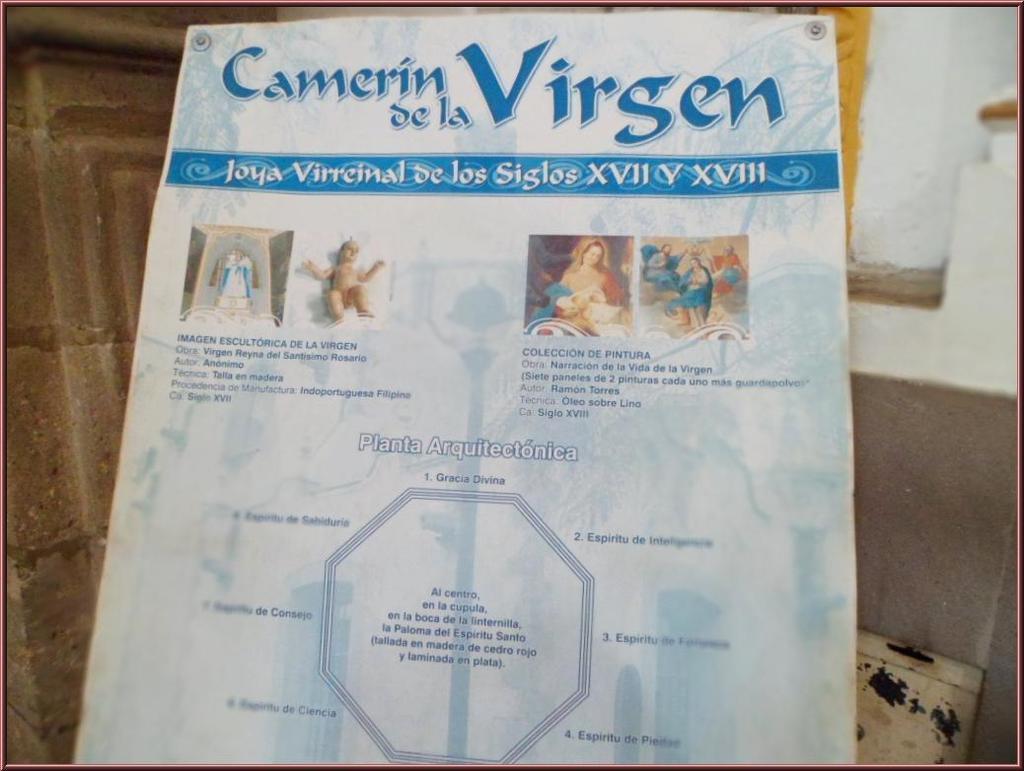How would you summarize this image in a sentence or two? There is a poster in the middle of this image and there is a wall in the background. 